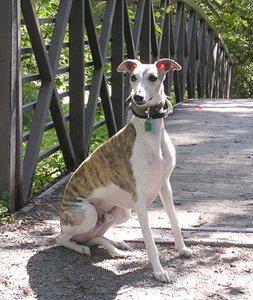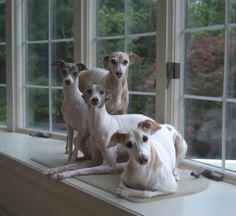The first image is the image on the left, the second image is the image on the right. For the images shown, is this caption "In one image, a dog is being cradled in a person's arm." true? Answer yes or no. No. The first image is the image on the left, the second image is the image on the right. Assess this claim about the two images: "The right image contains no more than one dog.". Correct or not? Answer yes or no. No. The first image is the image on the left, the second image is the image on the right. Examine the images to the left and right. Is the description "Several hounds are resting together on something manmade, neutral-colored and plush." accurate? Answer yes or no. Yes. The first image is the image on the left, the second image is the image on the right. Considering the images on both sides, is "There are more dogs in the right image than in the left." valid? Answer yes or no. Yes. 